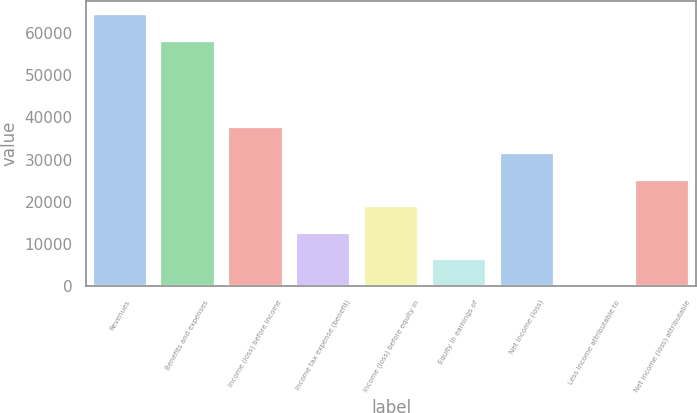Convert chart to OTSL. <chart><loc_0><loc_0><loc_500><loc_500><bar_chart><fcel>Revenues<fcel>Benefits and expenses<fcel>Income (loss) before income<fcel>Income tax expense (benefit)<fcel>Income (loss) before equity in<fcel>Equity in earnings of<fcel>Net income (loss)<fcel>Less Income attributable to<fcel>Net income (loss) attributable<nl><fcel>64455.8<fcel>58158<fcel>37800.8<fcel>12609.6<fcel>18907.4<fcel>6311.8<fcel>31503<fcel>14<fcel>25205.2<nl></chart> 